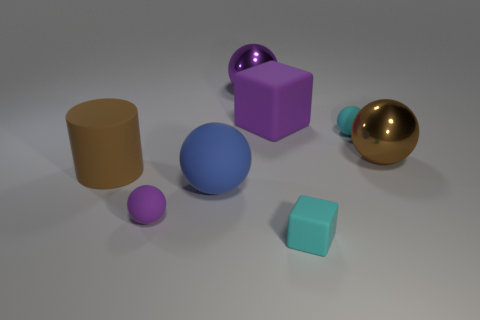Subtract all brown cubes. How many purple balls are left? 2 Subtract all large metallic balls. How many balls are left? 3 Subtract all purple balls. How many balls are left? 3 Subtract all gray balls. Subtract all blue blocks. How many balls are left? 5 Add 2 purple metallic spheres. How many objects exist? 10 Subtract all cubes. How many objects are left? 6 Subtract all green metal things. Subtract all small cyan spheres. How many objects are left? 7 Add 4 big purple balls. How many big purple balls are left? 5 Add 6 yellow matte balls. How many yellow matte balls exist? 6 Subtract 0 green spheres. How many objects are left? 8 